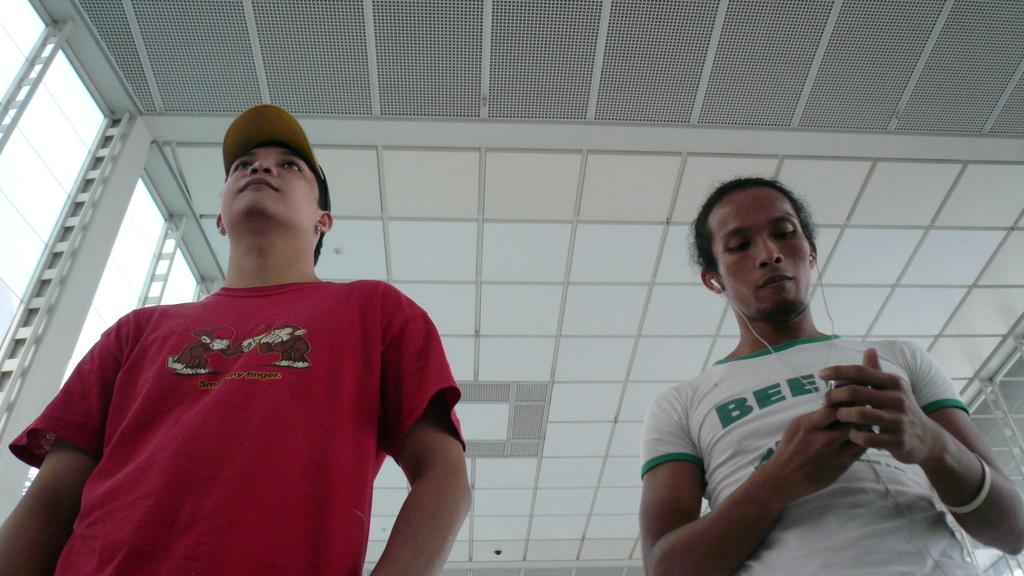How many people are in the image? There are people in the image, but the exact number is not specified. What is one person doing in the image? One person is wearing headphones. What is the person with headphones holding? The person with headphones is holding an object. What type of structure is visible in the image? There is a roof visible in the image. What architectural features can be seen in the image? There are poles in the image. What type of legal advice is the person with headphones seeking in the image? There is no indication in the image that the person with headphones is seeking legal advice or interacting with a lawyer. What type of bead is the person with headphones using to create a necklace in the image? There is no bead or necklace-making activity depicted in the image. 